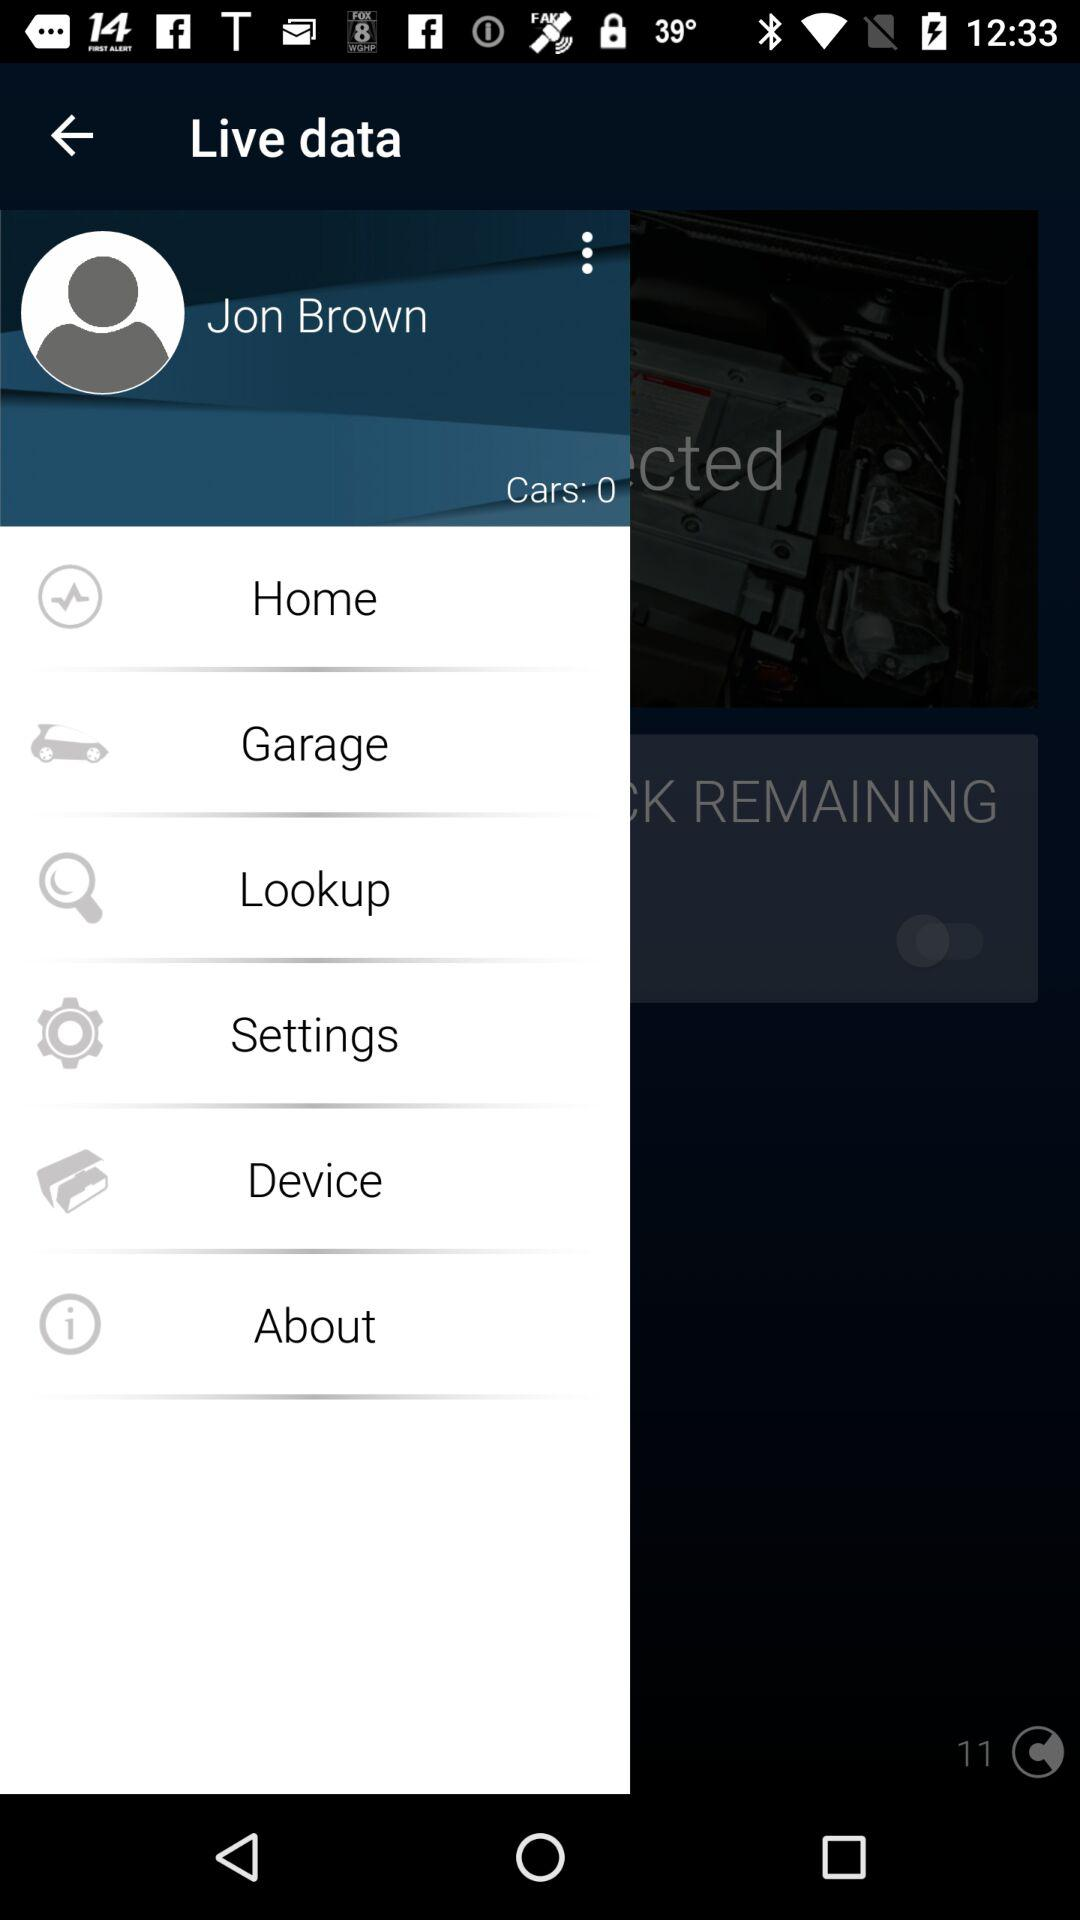What is the number of cars shown? The number of cars shown is 0. 